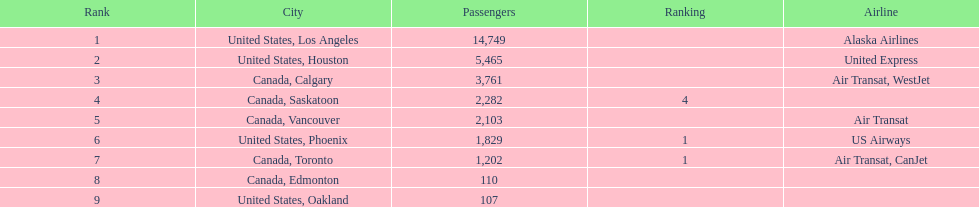In 2013, which city had the busiest international route at manzanillo international airport: los angeles or houston? Los Angeles. 